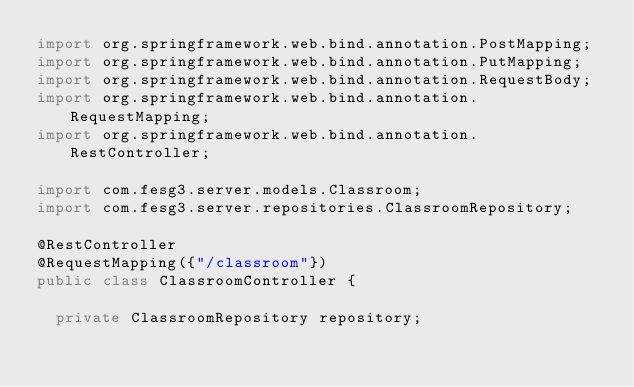<code> <loc_0><loc_0><loc_500><loc_500><_Java_>import org.springframework.web.bind.annotation.PostMapping;
import org.springframework.web.bind.annotation.PutMapping;
import org.springframework.web.bind.annotation.RequestBody;
import org.springframework.web.bind.annotation.RequestMapping;
import org.springframework.web.bind.annotation.RestController;

import com.fesg3.server.models.Classroom;
import com.fesg3.server.repositories.ClassroomRepository;

@RestController
@RequestMapping({"/classroom"})
public class ClassroomController {
	
	private ClassroomRepository repository;
	</code> 